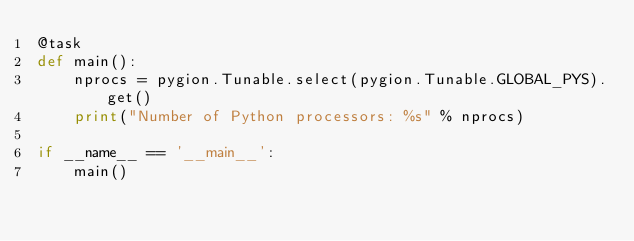<code> <loc_0><loc_0><loc_500><loc_500><_Python_>@task
def main():
    nprocs = pygion.Tunable.select(pygion.Tunable.GLOBAL_PYS).get()
    print("Number of Python processors: %s" % nprocs)

if __name__ == '__main__':
    main()
</code> 